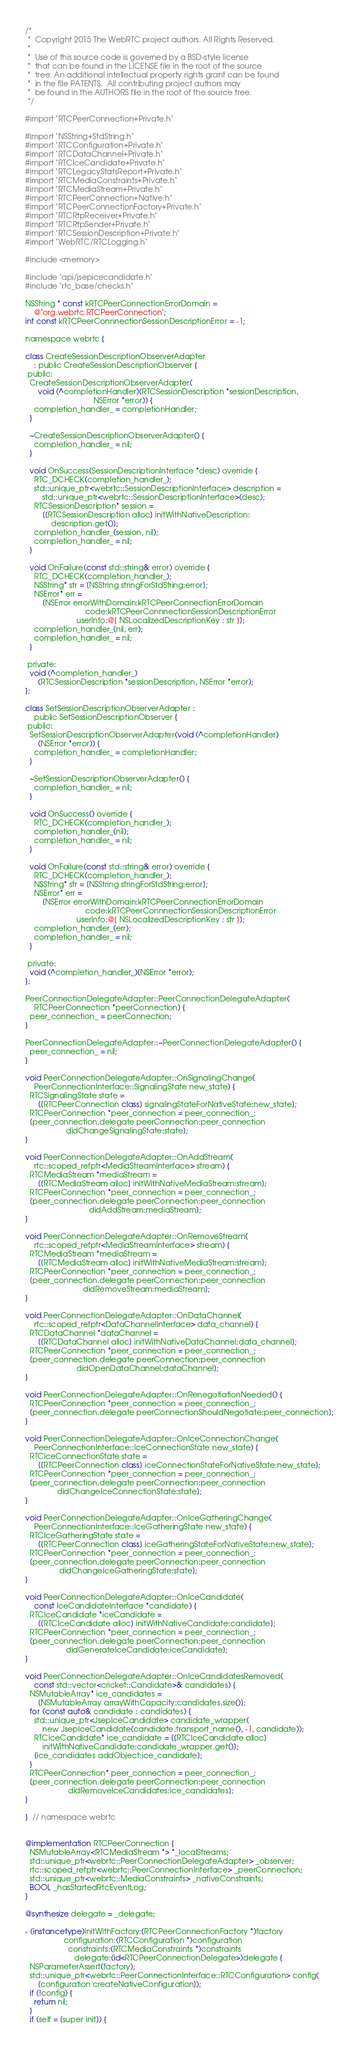Convert code to text. <code><loc_0><loc_0><loc_500><loc_500><_ObjectiveC_>/*
 *  Copyright 2015 The WebRTC project authors. All Rights Reserved.
 *
 *  Use of this source code is governed by a BSD-style license
 *  that can be found in the LICENSE file in the root of the source
 *  tree. An additional intellectual property rights grant can be found
 *  in the file PATENTS.  All contributing project authors may
 *  be found in the AUTHORS file in the root of the source tree.
 */

#import "RTCPeerConnection+Private.h"

#import "NSString+StdString.h"
#import "RTCConfiguration+Private.h"
#import "RTCDataChannel+Private.h"
#import "RTCIceCandidate+Private.h"
#import "RTCLegacyStatsReport+Private.h"
#import "RTCMediaConstraints+Private.h"
#import "RTCMediaStream+Private.h"
#import "RTCPeerConnection+Native.h"
#import "RTCPeerConnectionFactory+Private.h"
#import "RTCRtpReceiver+Private.h"
#import "RTCRtpSender+Private.h"
#import "RTCSessionDescription+Private.h"
#import "WebRTC/RTCLogging.h"

#include <memory>

#include "api/jsepicecandidate.h"
#include "rtc_base/checks.h"

NSString * const kRTCPeerConnectionErrorDomain =
    @"org.webrtc.RTCPeerConnection";
int const kRTCPeerConnnectionSessionDescriptionError = -1;

namespace webrtc {

class CreateSessionDescriptionObserverAdapter
    : public CreateSessionDescriptionObserver {
 public:
  CreateSessionDescriptionObserverAdapter(
      void (^completionHandler)(RTCSessionDescription *sessionDescription,
                                NSError *error)) {
    completion_handler_ = completionHandler;
  }

  ~CreateSessionDescriptionObserverAdapter() {
    completion_handler_ = nil;
  }

  void OnSuccess(SessionDescriptionInterface *desc) override {
    RTC_DCHECK(completion_handler_);
    std::unique_ptr<webrtc::SessionDescriptionInterface> description =
        std::unique_ptr<webrtc::SessionDescriptionInterface>(desc);
    RTCSessionDescription* session =
        [[RTCSessionDescription alloc] initWithNativeDescription:
            description.get()];
    completion_handler_(session, nil);
    completion_handler_ = nil;
  }

  void OnFailure(const std::string& error) override {
    RTC_DCHECK(completion_handler_);
    NSString* str = [NSString stringForStdString:error];
    NSError* err =
        [NSError errorWithDomain:kRTCPeerConnectionErrorDomain
                            code:kRTCPeerConnnectionSessionDescriptionError
                        userInfo:@{ NSLocalizedDescriptionKey : str }];
    completion_handler_(nil, err);
    completion_handler_ = nil;
  }

 private:
  void (^completion_handler_)
      (RTCSessionDescription *sessionDescription, NSError *error);
};

class SetSessionDescriptionObserverAdapter :
    public SetSessionDescriptionObserver {
 public:
  SetSessionDescriptionObserverAdapter(void (^completionHandler)
      (NSError *error)) {
    completion_handler_ = completionHandler;
  }

  ~SetSessionDescriptionObserverAdapter() {
    completion_handler_ = nil;
  }

  void OnSuccess() override {
    RTC_DCHECK(completion_handler_);
    completion_handler_(nil);
    completion_handler_ = nil;
  }

  void OnFailure(const std::string& error) override {
    RTC_DCHECK(completion_handler_);
    NSString* str = [NSString stringForStdString:error];
    NSError* err =
        [NSError errorWithDomain:kRTCPeerConnectionErrorDomain
                            code:kRTCPeerConnnectionSessionDescriptionError
                        userInfo:@{ NSLocalizedDescriptionKey : str }];
    completion_handler_(err);
    completion_handler_ = nil;
  }

 private:
  void (^completion_handler_)(NSError *error);
};

PeerConnectionDelegateAdapter::PeerConnectionDelegateAdapter(
    RTCPeerConnection *peerConnection) {
  peer_connection_ = peerConnection;
}

PeerConnectionDelegateAdapter::~PeerConnectionDelegateAdapter() {
  peer_connection_ = nil;
}

void PeerConnectionDelegateAdapter::OnSignalingChange(
    PeerConnectionInterface::SignalingState new_state) {
  RTCSignalingState state =
      [[RTCPeerConnection class] signalingStateForNativeState:new_state];
  RTCPeerConnection *peer_connection = peer_connection_;
  [peer_connection.delegate peerConnection:peer_connection
                   didChangeSignalingState:state];
}

void PeerConnectionDelegateAdapter::OnAddStream(
    rtc::scoped_refptr<MediaStreamInterface> stream) {
  RTCMediaStream *mediaStream =
      [[RTCMediaStream alloc] initWithNativeMediaStream:stream];
  RTCPeerConnection *peer_connection = peer_connection_;
  [peer_connection.delegate peerConnection:peer_connection
                              didAddStream:mediaStream];
}

void PeerConnectionDelegateAdapter::OnRemoveStream(
    rtc::scoped_refptr<MediaStreamInterface> stream) {
  RTCMediaStream *mediaStream =
      [[RTCMediaStream alloc] initWithNativeMediaStream:stream];
  RTCPeerConnection *peer_connection = peer_connection_;
  [peer_connection.delegate peerConnection:peer_connection
                           didRemoveStream:mediaStream];
}

void PeerConnectionDelegateAdapter::OnDataChannel(
    rtc::scoped_refptr<DataChannelInterface> data_channel) {
  RTCDataChannel *dataChannel =
      [[RTCDataChannel alloc] initWithNativeDataChannel:data_channel];
  RTCPeerConnection *peer_connection = peer_connection_;
  [peer_connection.delegate peerConnection:peer_connection
                        didOpenDataChannel:dataChannel];
}

void PeerConnectionDelegateAdapter::OnRenegotiationNeeded() {
  RTCPeerConnection *peer_connection = peer_connection_;
  [peer_connection.delegate peerConnectionShouldNegotiate:peer_connection];
}

void PeerConnectionDelegateAdapter::OnIceConnectionChange(
    PeerConnectionInterface::IceConnectionState new_state) {
  RTCIceConnectionState state =
      [[RTCPeerConnection class] iceConnectionStateForNativeState:new_state];
  RTCPeerConnection *peer_connection = peer_connection_;
  [peer_connection.delegate peerConnection:peer_connection
               didChangeIceConnectionState:state];
}

void PeerConnectionDelegateAdapter::OnIceGatheringChange(
    PeerConnectionInterface::IceGatheringState new_state) {
  RTCIceGatheringState state =
      [[RTCPeerConnection class] iceGatheringStateForNativeState:new_state];
  RTCPeerConnection *peer_connection = peer_connection_;
  [peer_connection.delegate peerConnection:peer_connection
                didChangeIceGatheringState:state];
}

void PeerConnectionDelegateAdapter::OnIceCandidate(
    const IceCandidateInterface *candidate) {
  RTCIceCandidate *iceCandidate =
      [[RTCIceCandidate alloc] initWithNativeCandidate:candidate];
  RTCPeerConnection *peer_connection = peer_connection_;
  [peer_connection.delegate peerConnection:peer_connection
                   didGenerateIceCandidate:iceCandidate];
}

void PeerConnectionDelegateAdapter::OnIceCandidatesRemoved(
    const std::vector<cricket::Candidate>& candidates) {
  NSMutableArray* ice_candidates =
      [NSMutableArray arrayWithCapacity:candidates.size()];
  for (const auto& candidate : candidates) {
    std::unique_ptr<JsepIceCandidate> candidate_wrapper(
        new JsepIceCandidate(candidate.transport_name(), -1, candidate));
    RTCIceCandidate* ice_candidate = [[RTCIceCandidate alloc]
        initWithNativeCandidate:candidate_wrapper.get()];
    [ice_candidates addObject:ice_candidate];
  }
  RTCPeerConnection* peer_connection = peer_connection_;
  [peer_connection.delegate peerConnection:peer_connection
                    didRemoveIceCandidates:ice_candidates];
}

}  // namespace webrtc


@implementation RTCPeerConnection {
  NSMutableArray<RTCMediaStream *> *_localStreams;
  std::unique_ptr<webrtc::PeerConnectionDelegateAdapter> _observer;
  rtc::scoped_refptr<webrtc::PeerConnectionInterface> _peerConnection;
  std::unique_ptr<webrtc::MediaConstraints> _nativeConstraints;
  BOOL _hasStartedRtcEventLog;
}

@synthesize delegate = _delegate;

- (instancetype)initWithFactory:(RTCPeerConnectionFactory *)factory
                  configuration:(RTCConfiguration *)configuration
                    constraints:(RTCMediaConstraints *)constraints
                       delegate:(id<RTCPeerConnectionDelegate>)delegate {
  NSParameterAssert(factory);
  std::unique_ptr<webrtc::PeerConnectionInterface::RTCConfiguration> config(
      [configuration createNativeConfiguration]);
  if (!config) {
    return nil;
  }
  if (self = [super init]) {</code> 